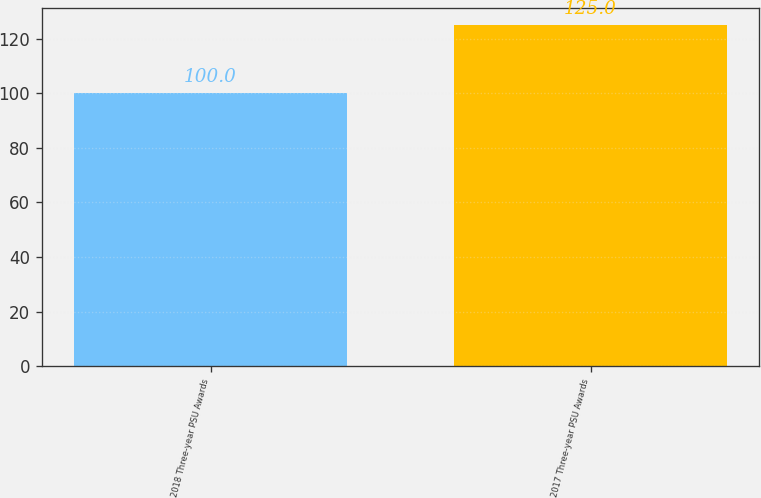Convert chart. <chart><loc_0><loc_0><loc_500><loc_500><bar_chart><fcel>2018 Three-year PSU Awards<fcel>2017 Three-year PSU Awards<nl><fcel>100<fcel>125<nl></chart> 